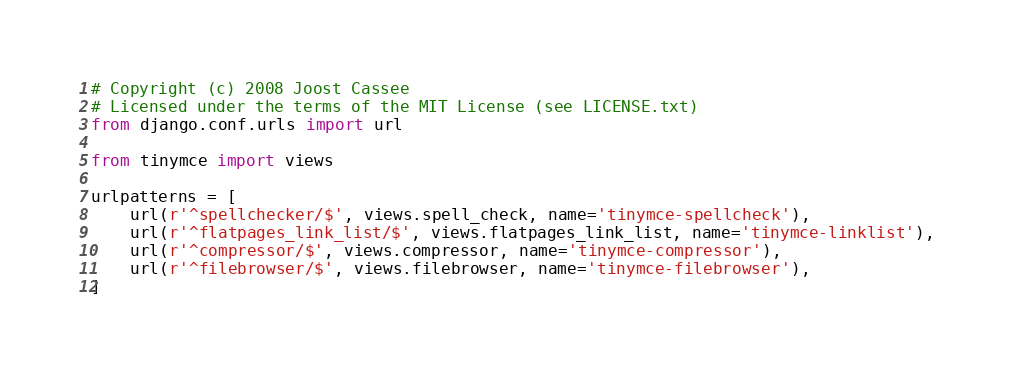Convert code to text. <code><loc_0><loc_0><loc_500><loc_500><_Python_># Copyright (c) 2008 Joost Cassee
# Licensed under the terms of the MIT License (see LICENSE.txt)
from django.conf.urls import url

from tinymce import views

urlpatterns = [
    url(r'^spellchecker/$', views.spell_check, name='tinymce-spellcheck'),
    url(r'^flatpages_link_list/$', views.flatpages_link_list, name='tinymce-linklist'),
    url(r'^compressor/$', views.compressor, name='tinymce-compressor'),
    url(r'^filebrowser/$', views.filebrowser, name='tinymce-filebrowser'),
]
</code> 